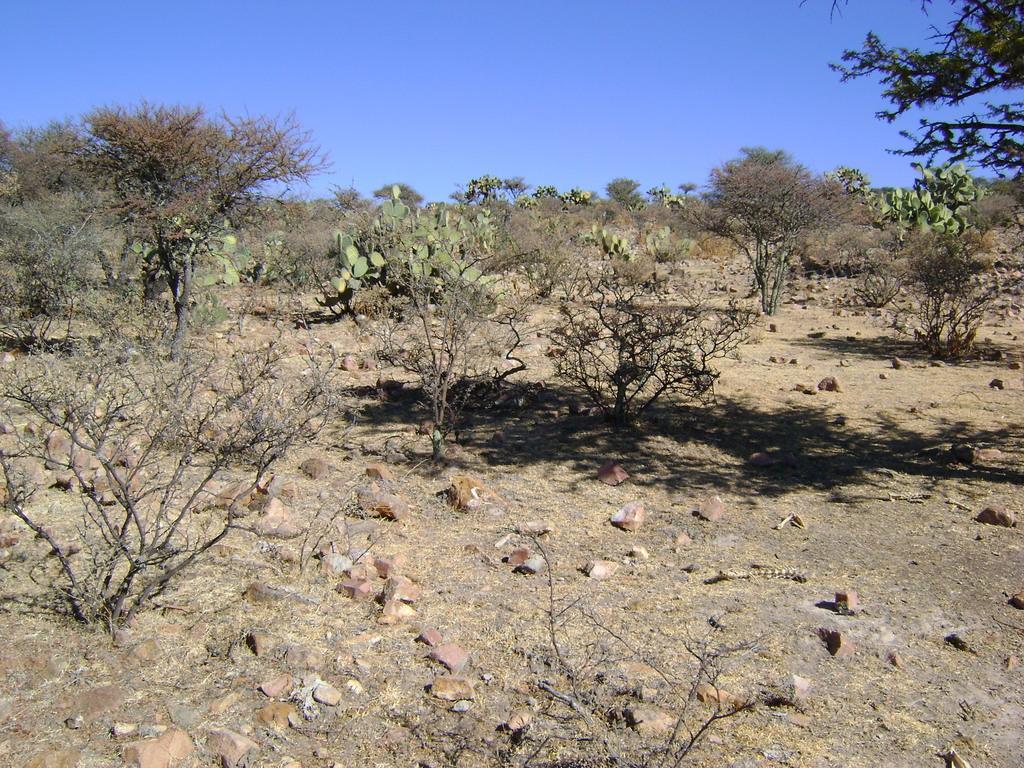Please provide a concise description of this image. In this image I can see the ground, few rocks on the ground and few trees which are brown and green in color. In the background I can see the sky. 